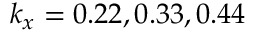Convert formula to latex. <formula><loc_0><loc_0><loc_500><loc_500>k _ { x } = 0 . 2 2 , 0 . 3 3 , 0 . 4 4</formula> 